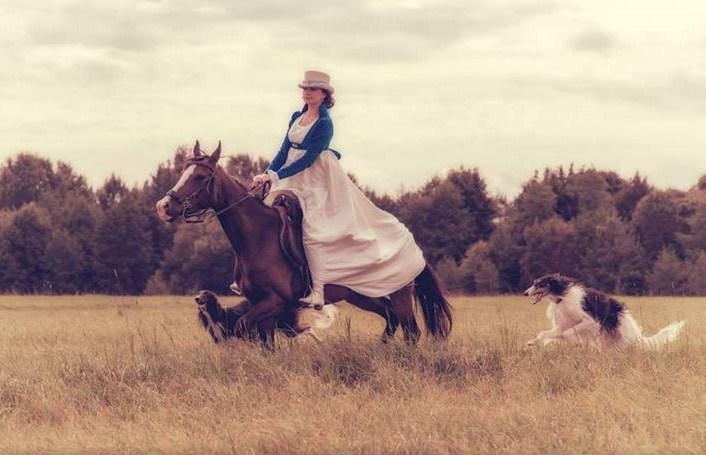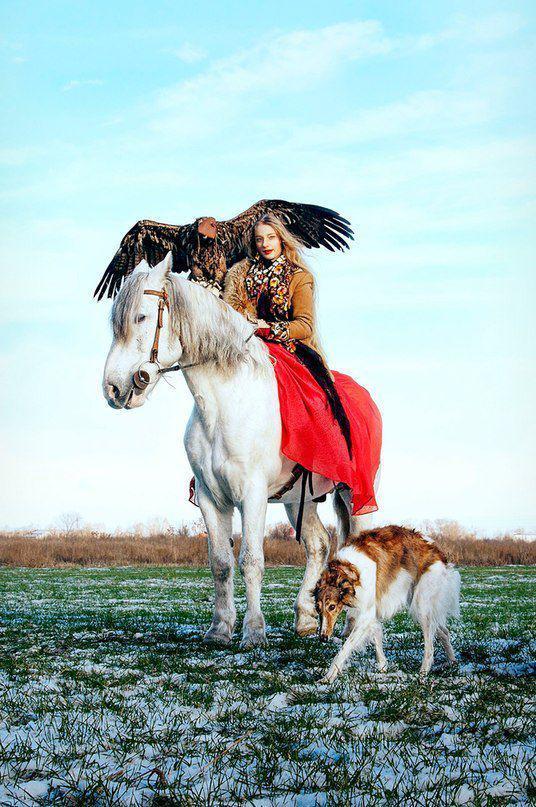The first image is the image on the left, the second image is the image on the right. Given the left and right images, does the statement "One image shows at least one hound in a raft on water, and the other image shows a hound that is upright and trotting." hold true? Answer yes or no. No. The first image is the image on the left, the second image is the image on the right. Analyze the images presented: Is the assertion "An image contains at least one dog inside an inflatable flotation device." valid? Answer yes or no. No. 